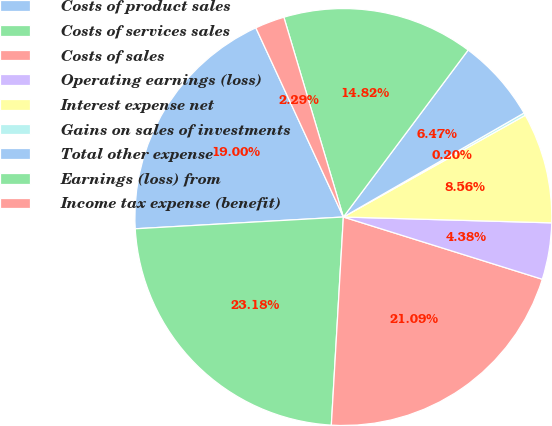<chart> <loc_0><loc_0><loc_500><loc_500><pie_chart><fcel>Costs of product sales<fcel>Costs of services sales<fcel>Costs of sales<fcel>Operating earnings (loss)<fcel>Interest expense net<fcel>Gains on sales of investments<fcel>Total other expense<fcel>Earnings (loss) from<fcel>Income tax expense (benefit)<nl><fcel>19.0%<fcel>23.18%<fcel>21.09%<fcel>4.38%<fcel>8.56%<fcel>0.2%<fcel>6.47%<fcel>14.82%<fcel>2.29%<nl></chart> 